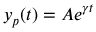Convert formula to latex. <formula><loc_0><loc_0><loc_500><loc_500>y _ { p } ( t ) = A e ^ { \gamma t }</formula> 